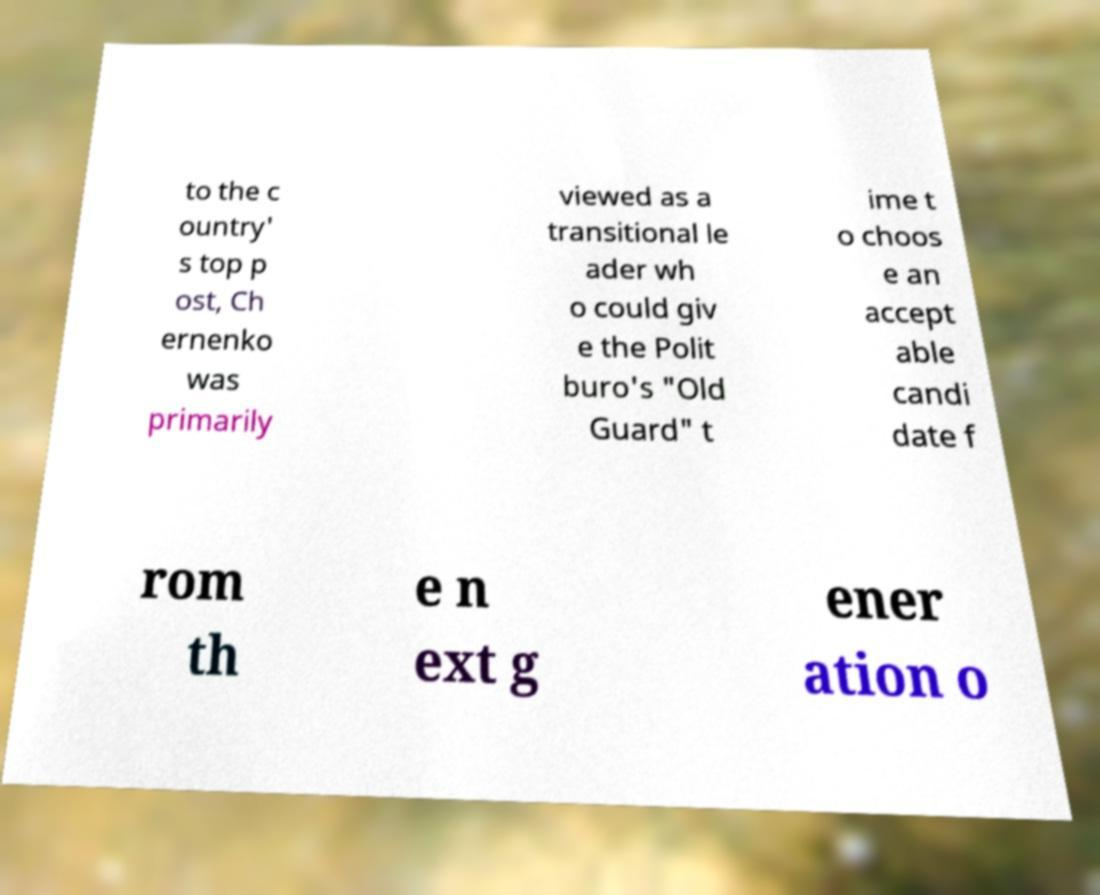There's text embedded in this image that I need extracted. Can you transcribe it verbatim? to the c ountry' s top p ost, Ch ernenko was primarily viewed as a transitional le ader wh o could giv e the Polit buro's "Old Guard" t ime t o choos e an accept able candi date f rom th e n ext g ener ation o 